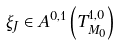<formula> <loc_0><loc_0><loc_500><loc_500>\xi _ { J } \in A ^ { 0 , 1 } \left ( T _ { M _ { 0 } } ^ { 1 , 0 } \right )</formula> 